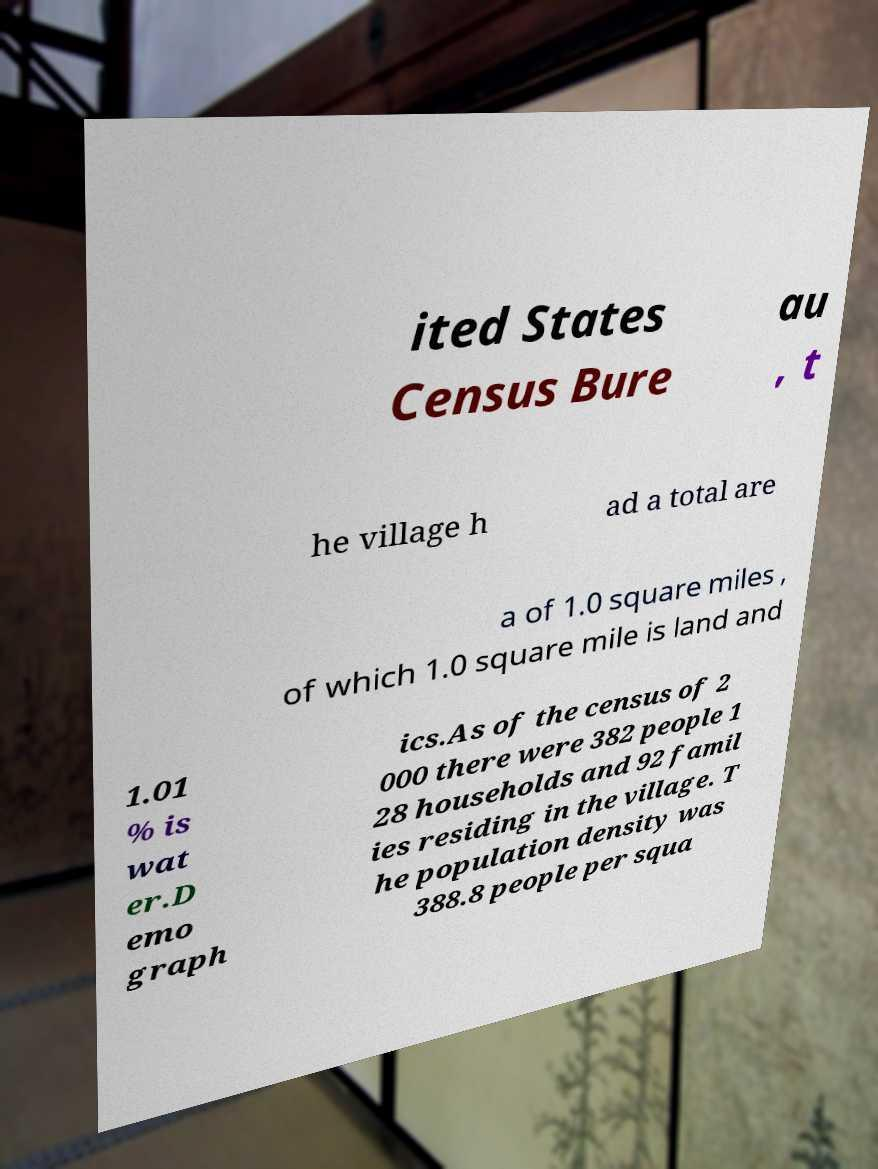I need the written content from this picture converted into text. Can you do that? ited States Census Bure au , t he village h ad a total are a of 1.0 square miles , of which 1.0 square mile is land and 1.01 % is wat er.D emo graph ics.As of the census of 2 000 there were 382 people 1 28 households and 92 famil ies residing in the village. T he population density was 388.8 people per squa 